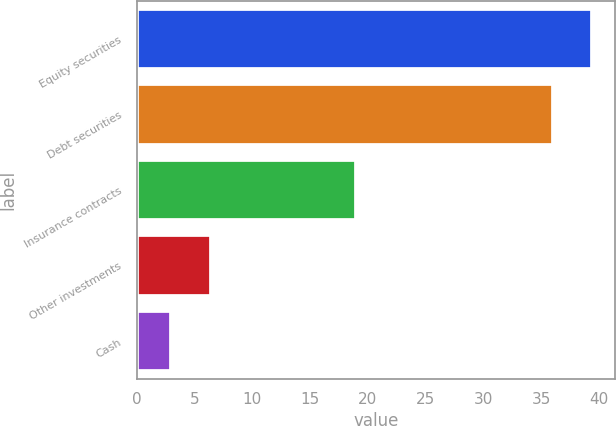Convert chart to OTSL. <chart><loc_0><loc_0><loc_500><loc_500><bar_chart><fcel>Equity securities<fcel>Debt securities<fcel>Insurance contracts<fcel>Other investments<fcel>Cash<nl><fcel>39.4<fcel>36<fcel>19<fcel>6.4<fcel>3<nl></chart> 